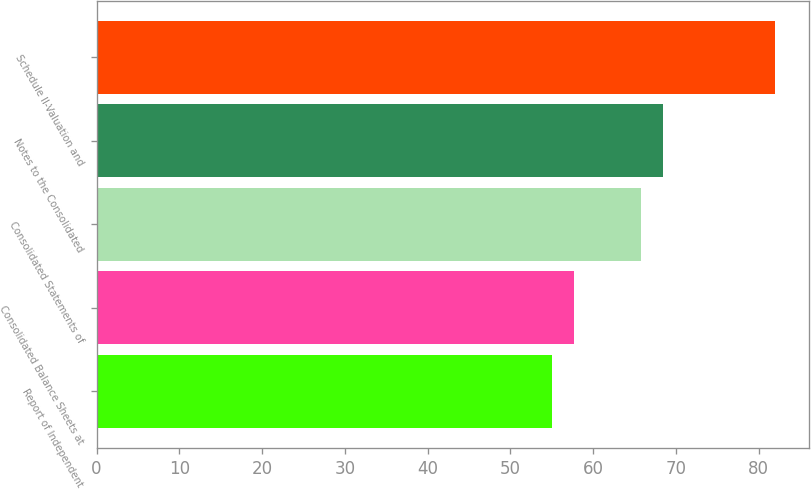Convert chart. <chart><loc_0><loc_0><loc_500><loc_500><bar_chart><fcel>Report of Independent<fcel>Consolidated Balance Sheets at<fcel>Consolidated Statements of<fcel>Notes to the Consolidated<fcel>Schedule II-Valuation and<nl><fcel>55<fcel>57.7<fcel>65.8<fcel>68.5<fcel>82<nl></chart> 